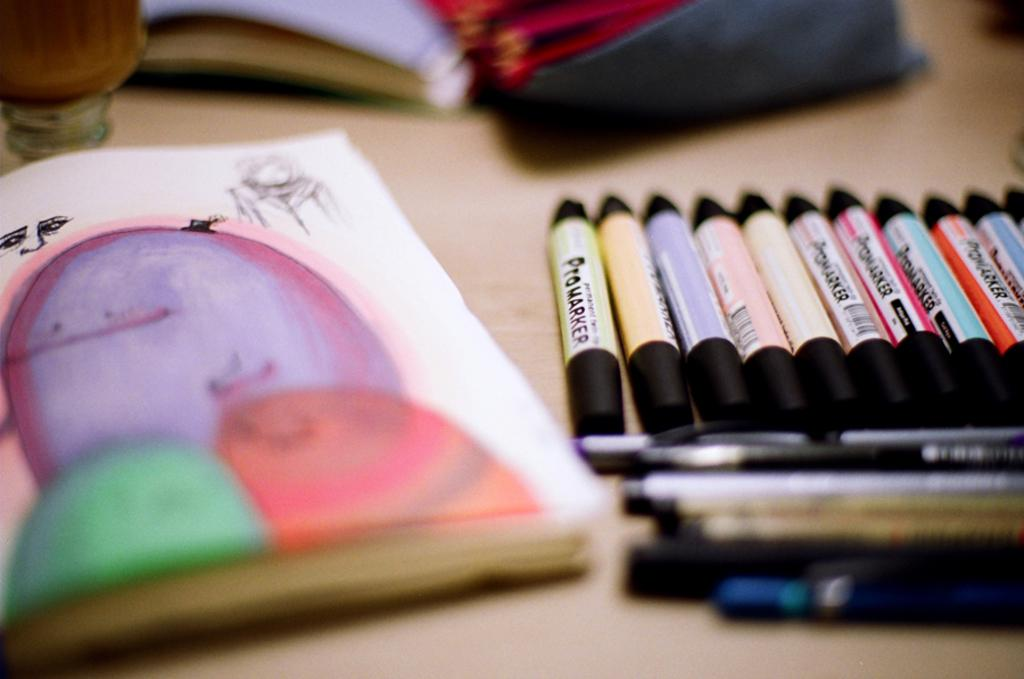<image>
Summarize the visual content of the image. Various colors of Promarkers are lined up by a colorful drawing. 